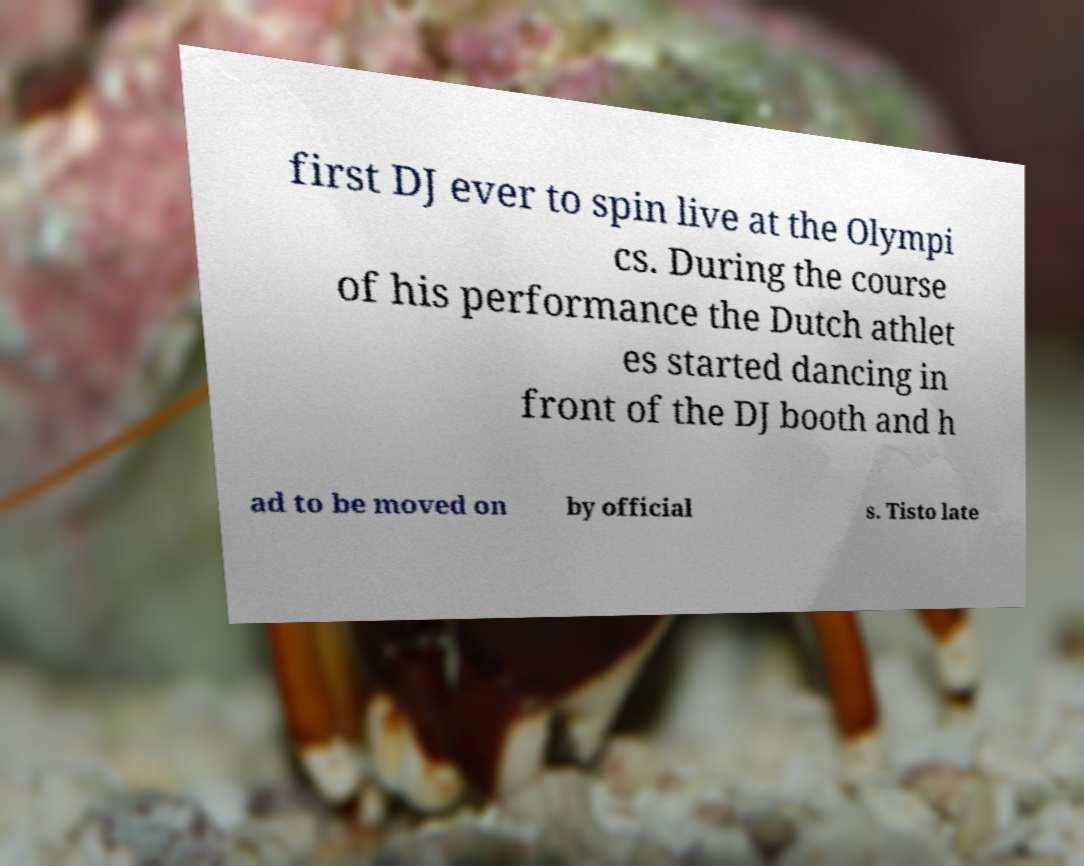Could you extract and type out the text from this image? first DJ ever to spin live at the Olympi cs. During the course of his performance the Dutch athlet es started dancing in front of the DJ booth and h ad to be moved on by official s. Tisto late 